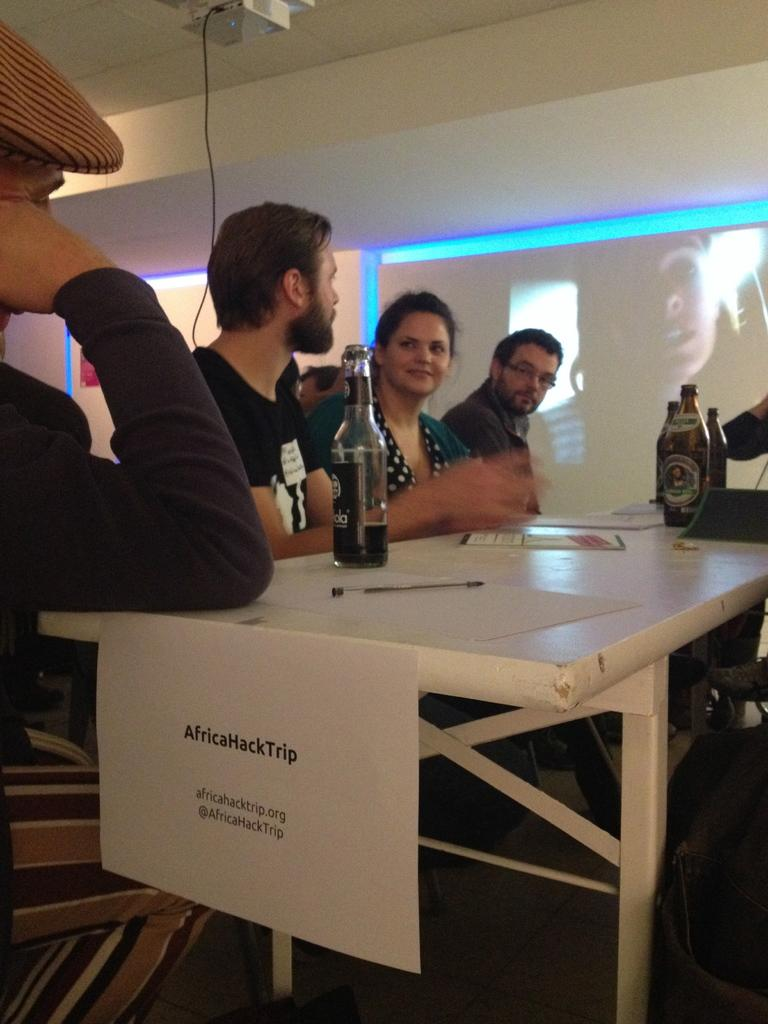What are the people in the image doing? The people in the image are sitting on chairs. What is present in the image besides the people? There is a table in the image. What can be seen on the table? There is a wine bottle on the table. What type of monkey is sitting on the chair next to the person in the image? There is no monkey present in the image; only people sitting on chairs are visible. 